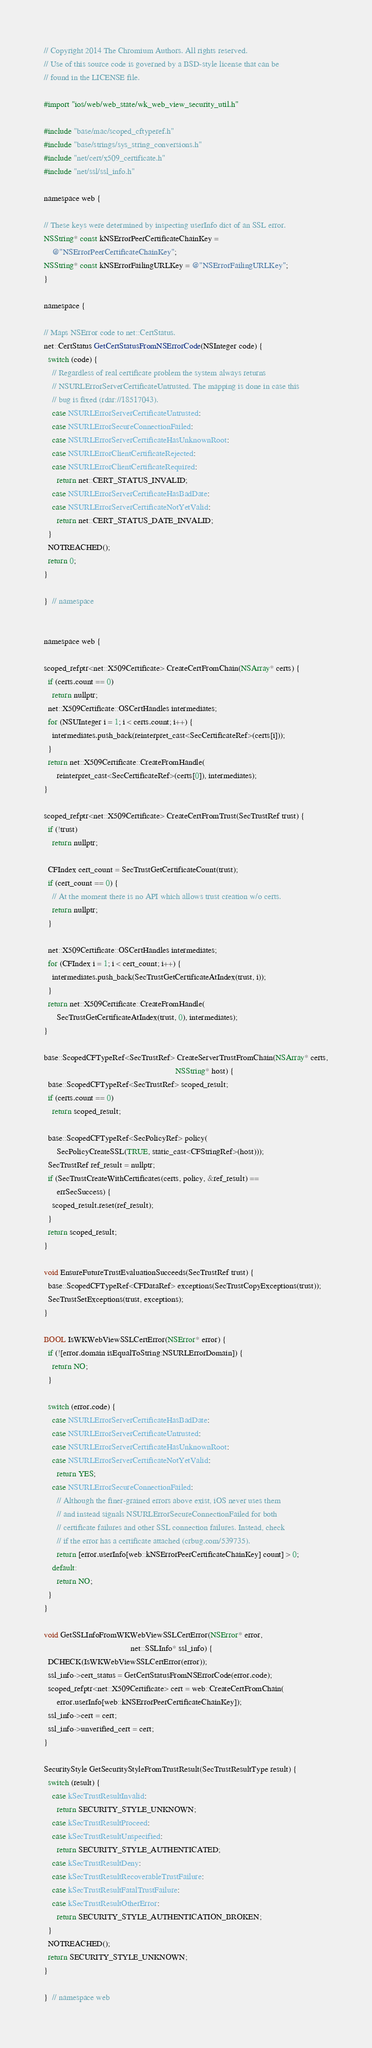Convert code to text. <code><loc_0><loc_0><loc_500><loc_500><_ObjectiveC_>// Copyright 2014 The Chromium Authors. All rights reserved.
// Use of this source code is governed by a BSD-style license that can be
// found in the LICENSE file.

#import "ios/web/web_state/wk_web_view_security_util.h"

#include "base/mac/scoped_cftyperef.h"
#include "base/strings/sys_string_conversions.h"
#include "net/cert/x509_certificate.h"
#include "net/ssl/ssl_info.h"

namespace web {

// These keys were determined by inspecting userInfo dict of an SSL error.
NSString* const kNSErrorPeerCertificateChainKey =
    @"NSErrorPeerCertificateChainKey";
NSString* const kNSErrorFailingURLKey = @"NSErrorFailingURLKey";
}

namespace {

// Maps NSError code to net::CertStatus.
net::CertStatus GetCertStatusFromNSErrorCode(NSInteger code) {
  switch (code) {
    // Regardless of real certificate problem the system always returns
    // NSURLErrorServerCertificateUntrusted. The mapping is done in case this
    // bug is fixed (rdar://18517043).
    case NSURLErrorServerCertificateUntrusted:
    case NSURLErrorSecureConnectionFailed:
    case NSURLErrorServerCertificateHasUnknownRoot:
    case NSURLErrorClientCertificateRejected:
    case NSURLErrorClientCertificateRequired:
      return net::CERT_STATUS_INVALID;
    case NSURLErrorServerCertificateHasBadDate:
    case NSURLErrorServerCertificateNotYetValid:
      return net::CERT_STATUS_DATE_INVALID;
  }
  NOTREACHED();
  return 0;
}

}  // namespace


namespace web {

scoped_refptr<net::X509Certificate> CreateCertFromChain(NSArray* certs) {
  if (certs.count == 0)
    return nullptr;
  net::X509Certificate::OSCertHandles intermediates;
  for (NSUInteger i = 1; i < certs.count; i++) {
    intermediates.push_back(reinterpret_cast<SecCertificateRef>(certs[i]));
  }
  return net::X509Certificate::CreateFromHandle(
      reinterpret_cast<SecCertificateRef>(certs[0]), intermediates);
}

scoped_refptr<net::X509Certificate> CreateCertFromTrust(SecTrustRef trust) {
  if (!trust)
    return nullptr;

  CFIndex cert_count = SecTrustGetCertificateCount(trust);
  if (cert_count == 0) {
    // At the moment there is no API which allows trust creation w/o certs.
    return nullptr;
  }

  net::X509Certificate::OSCertHandles intermediates;
  for (CFIndex i = 1; i < cert_count; i++) {
    intermediates.push_back(SecTrustGetCertificateAtIndex(trust, i));
  }
  return net::X509Certificate::CreateFromHandle(
      SecTrustGetCertificateAtIndex(trust, 0), intermediates);
}

base::ScopedCFTypeRef<SecTrustRef> CreateServerTrustFromChain(NSArray* certs,
                                                              NSString* host) {
  base::ScopedCFTypeRef<SecTrustRef> scoped_result;
  if (certs.count == 0)
    return scoped_result;

  base::ScopedCFTypeRef<SecPolicyRef> policy(
      SecPolicyCreateSSL(TRUE, static_cast<CFStringRef>(host)));
  SecTrustRef ref_result = nullptr;
  if (SecTrustCreateWithCertificates(certs, policy, &ref_result) ==
      errSecSuccess) {
    scoped_result.reset(ref_result);
  }
  return scoped_result;
}

void EnsureFutureTrustEvaluationSucceeds(SecTrustRef trust) {
  base::ScopedCFTypeRef<CFDataRef> exceptions(SecTrustCopyExceptions(trust));
  SecTrustSetExceptions(trust, exceptions);
}

BOOL IsWKWebViewSSLCertError(NSError* error) {
  if (![error.domain isEqualToString:NSURLErrorDomain]) {
    return NO;
  }

  switch (error.code) {
    case NSURLErrorServerCertificateHasBadDate:
    case NSURLErrorServerCertificateUntrusted:
    case NSURLErrorServerCertificateHasUnknownRoot:
    case NSURLErrorServerCertificateNotYetValid:
      return YES;
    case NSURLErrorSecureConnectionFailed:
      // Although the finer-grained errors above exist, iOS never uses them
      // and instead signals NSURLErrorSecureConnectionFailed for both
      // certificate failures and other SSL connection failures. Instead, check
      // if the error has a certificate attached (crbug.com/539735).
      return [error.userInfo[web::kNSErrorPeerCertificateChainKey] count] > 0;
    default:
      return NO;
  }
}

void GetSSLInfoFromWKWebViewSSLCertError(NSError* error,
                                         net::SSLInfo* ssl_info) {
  DCHECK(IsWKWebViewSSLCertError(error));
  ssl_info->cert_status = GetCertStatusFromNSErrorCode(error.code);
  scoped_refptr<net::X509Certificate> cert = web::CreateCertFromChain(
      error.userInfo[web::kNSErrorPeerCertificateChainKey]);
  ssl_info->cert = cert;
  ssl_info->unverified_cert = cert;
}

SecurityStyle GetSecurityStyleFromTrustResult(SecTrustResultType result) {
  switch (result) {
    case kSecTrustResultInvalid:
      return SECURITY_STYLE_UNKNOWN;
    case kSecTrustResultProceed:
    case kSecTrustResultUnspecified:
      return SECURITY_STYLE_AUTHENTICATED;
    case kSecTrustResultDeny:
    case kSecTrustResultRecoverableTrustFailure:
    case kSecTrustResultFatalTrustFailure:
    case kSecTrustResultOtherError:
      return SECURITY_STYLE_AUTHENTICATION_BROKEN;
  }
  NOTREACHED();
  return SECURITY_STYLE_UNKNOWN;
}

}  // namespace web
</code> 